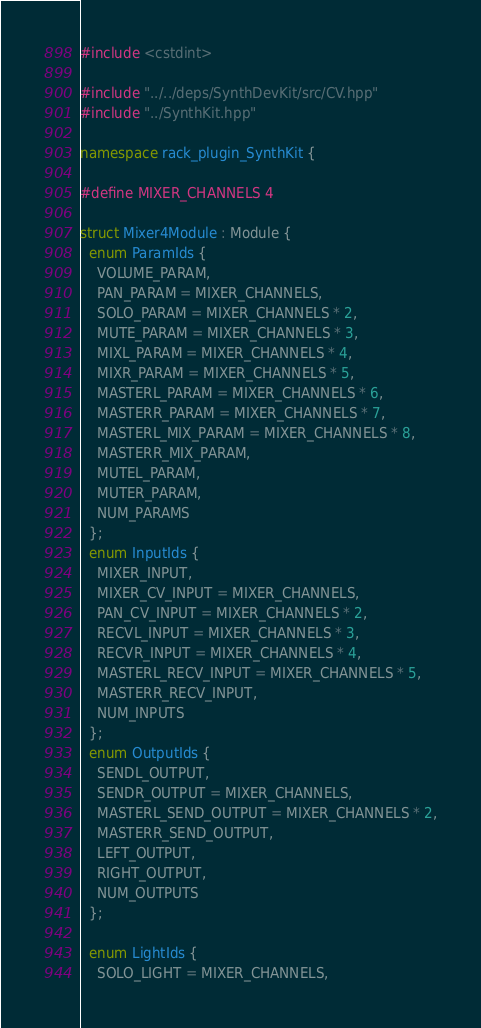<code> <loc_0><loc_0><loc_500><loc_500><_C++_>#include <cstdint>

#include "../../deps/SynthDevKit/src/CV.hpp"
#include "../SynthKit.hpp"

namespace rack_plugin_SynthKit {

#define MIXER_CHANNELS 4

struct Mixer4Module : Module {
  enum ParamIds {
    VOLUME_PARAM,
    PAN_PARAM = MIXER_CHANNELS,
    SOLO_PARAM = MIXER_CHANNELS * 2,
    MUTE_PARAM = MIXER_CHANNELS * 3,
    MIXL_PARAM = MIXER_CHANNELS * 4,
    MIXR_PARAM = MIXER_CHANNELS * 5,
    MASTERL_PARAM = MIXER_CHANNELS * 6,
    MASTERR_PARAM = MIXER_CHANNELS * 7,
    MASTERL_MIX_PARAM = MIXER_CHANNELS * 8,
    MASTERR_MIX_PARAM,
    MUTEL_PARAM,
    MUTER_PARAM,
    NUM_PARAMS
  };
  enum InputIds {
    MIXER_INPUT,
    MIXER_CV_INPUT = MIXER_CHANNELS,
    PAN_CV_INPUT = MIXER_CHANNELS * 2,
    RECVL_INPUT = MIXER_CHANNELS * 3,
    RECVR_INPUT = MIXER_CHANNELS * 4,
    MASTERL_RECV_INPUT = MIXER_CHANNELS * 5,
    MASTERR_RECV_INPUT,
    NUM_INPUTS
  };
  enum OutputIds {
    SENDL_OUTPUT,
    SENDR_OUTPUT = MIXER_CHANNELS,
    MASTERL_SEND_OUTPUT = MIXER_CHANNELS * 2,
    MASTERR_SEND_OUTPUT,
    LEFT_OUTPUT,
    RIGHT_OUTPUT,
    NUM_OUTPUTS
  };

  enum LightIds {
    SOLO_LIGHT = MIXER_CHANNELS,</code> 